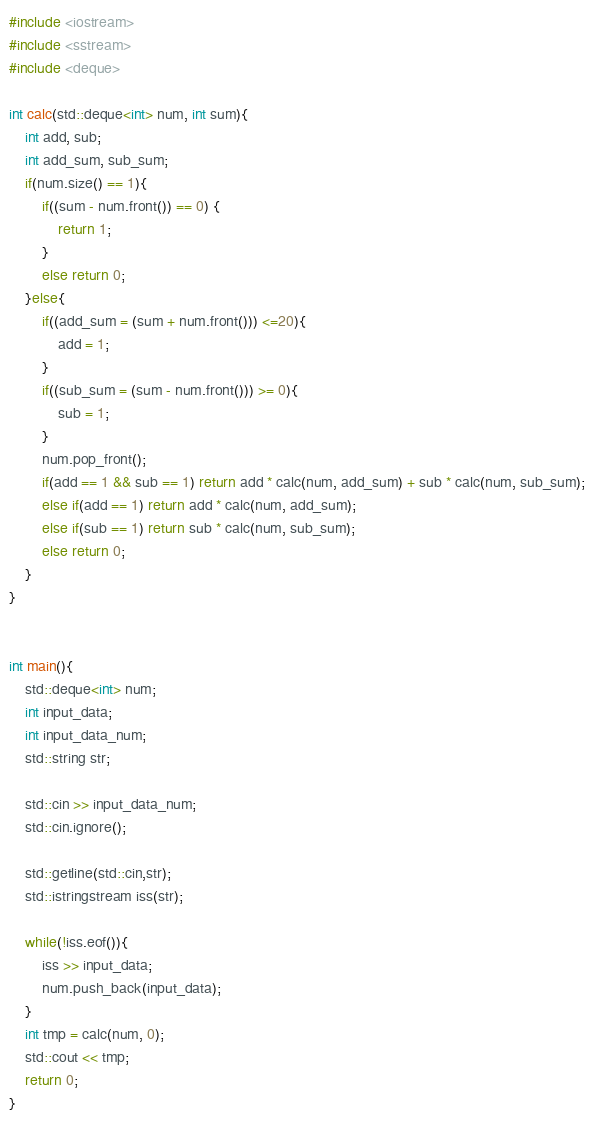<code> <loc_0><loc_0><loc_500><loc_500><_C++_>#include <iostream>
#include <sstream>
#include <deque>

int calc(std::deque<int> num, int sum){
    int add, sub;
    int add_sum, sub_sum;
    if(num.size() == 1){
        if((sum - num.front()) == 0) {
            return 1;
        }
        else return 0;
    }else{
        if((add_sum = (sum + num.front())) <=20){
            add = 1;
        }
        if((sub_sum = (sum - num.front())) >= 0){
            sub = 1;
        }
        num.pop_front();
        if(add == 1 && sub == 1) return add * calc(num, add_sum) + sub * calc(num, sub_sum);
        else if(add == 1) return add * calc(num, add_sum);
        else if(sub == 1) return sub * calc(num, sub_sum);
        else return 0;
    }
}


int main(){
    std::deque<int> num;
    int input_data;
    int input_data_num;
    std::string str;

    std::cin >> input_data_num;
    std::cin.ignore();

    std::getline(std::cin,str);
    std::istringstream iss(str);

    while(!iss.eof()){
        iss >> input_data;
        num.push_back(input_data);
    }
    int tmp = calc(num, 0);
    std::cout << tmp;
    return 0;
}</code> 